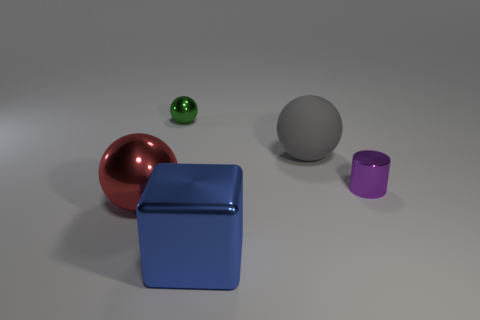Subtract 1 balls. How many balls are left? 2 Add 4 tiny red matte spheres. How many objects exist? 9 Subtract all spheres. How many objects are left? 2 Subtract 0 brown cylinders. How many objects are left? 5 Subtract all large red shiny things. Subtract all rubber objects. How many objects are left? 3 Add 3 green metal things. How many green metal things are left? 4 Add 5 large metal spheres. How many large metal spheres exist? 6 